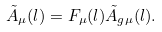<formula> <loc_0><loc_0><loc_500><loc_500>\tilde { A } _ { \mu } ( l ) = F _ { \mu } ( l ) \tilde { A } _ { g \mu } ( l ) .</formula> 